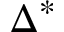<formula> <loc_0><loc_0><loc_500><loc_500>\Delta ^ { * }</formula> 